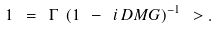<formula> <loc_0><loc_0><loc_500><loc_500>1 \ = \ \Gamma \ ( 1 \ - \ i \, D M G ) ^ { - 1 } \ > .</formula> 